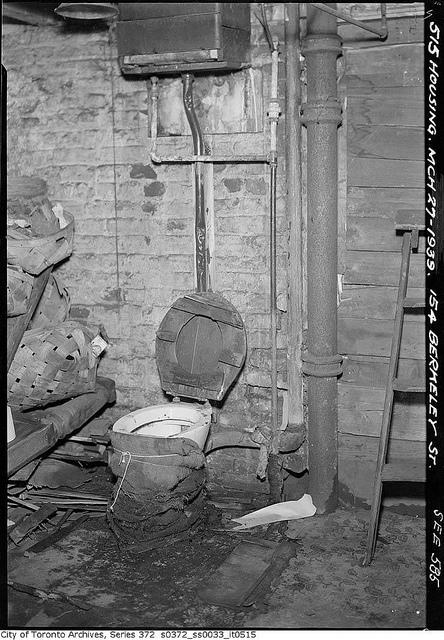What is the date on the photo?
Answer briefly. 1989. How many photos in one?
Keep it brief. 1. Is this outside?
Short answer required. No. What object is behind the pole?
Short answer required. Wall. Is this a black and white picture?
Concise answer only. Yes. What is the building made out of?
Give a very brief answer. Brick. Where is the image taken?
Give a very brief answer. Bathroom. Is that a fire hydrant?
Answer briefly. No. Are those bricks machine or man-made?
Quick response, please. Machine. How many steps are on the ladder?
Give a very brief answer. 3. Would you want to use this toilet?
Give a very brief answer. No. Is there an animal?
Answer briefly. No. 